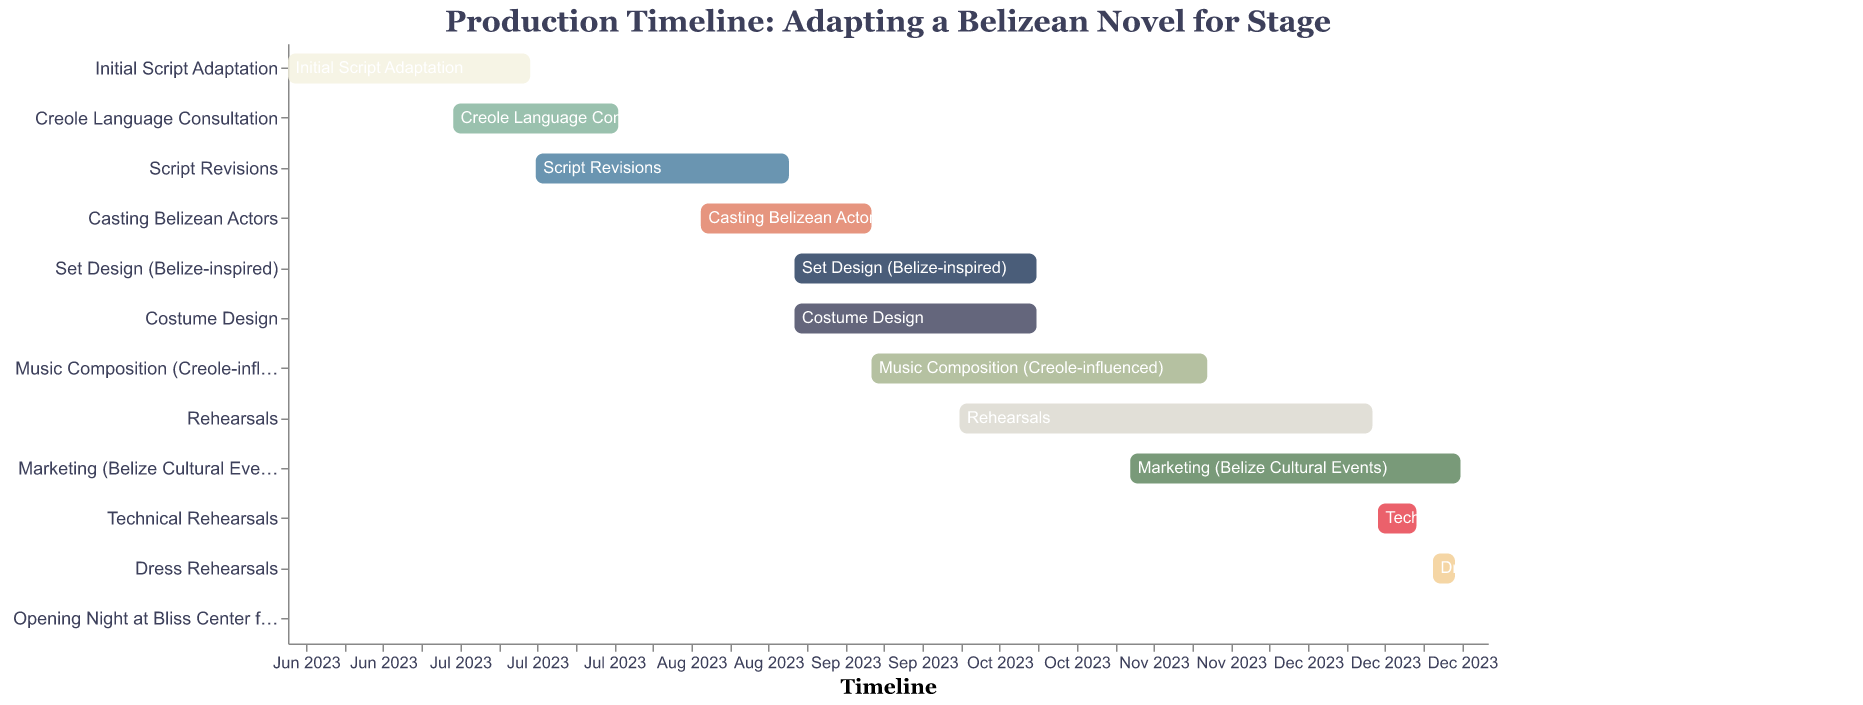What is the title of the Gantt Chart? The title of the chart is stated at the top of the figure, and it reads "Production Timeline: Adapting a Belizean Novel for Stage".
Answer: Production Timeline: Adapting a Belizean Novel for Stage Which task starts on 2023-09-01 and ends on 2023-10-15? By looking at the chart and examining tasks that span from 2023-09-01 to 2023-10-15, "Set Design (Belize-inspired)" and "Costume Design" fit these criteria.
Answer: Set Design (Belize-inspired), Costume Design How long does the "Rehearsals" task last? Observing the timeline for "Rehearsals", the task starts on 2023-10-01 and ends on 2023-12-15. To find the duration, count the months: October, November, and half of December, which totals to approximately 2.5 months.
Answer: 2.5 months Which task directly follows the "Initial Script Adaptation"? The "Initial Script Adaptation" ends on 2023-07-15. The next task starting after this date is "Script Revisions", which starts on 2023-07-16.
Answer: Script Revisions What is the time overlap between "Music Composition (Creole-influenced)" and "Rehearsals"? "Music Composition (Creole-influenced)" starts on 2023-09-15 and ends on 2023-11-15. "Rehearsals" starts on 2023-10-01 and ends on 2023-12-15. The overlap is from 2023-10-01 to 2023-11-15, which is 1.5 months.
Answer: 1.5 months How many tasks are related to design? Observing the Gantt Chart, "Set Design (Belize-inspired)" and "Costume Design" are tasks specifically related to design; hence there are two.
Answer: 2 What is the shortest task in the timeline? The shortest task in the timeline is "Opening Night at Bliss Center for Performing Arts", which occurs on one day, 2024-01-05.
Answer: Opening Night at Bliss Center for Performing Arts What is the duration of "Marketing (Belize Cultural Events)"? "Marketing (Belize Cultural Events)" starts on 2023-11-01 and ends on 2023-12-31. This period covers November and December, making it 2 months long.
Answer: 2 months When does "Casting Belizean Actors" start and end? The "Casting Belizean Actors" task starts on 2023-08-15 and ends on 2023-09-15, according to its position on the Gantt Chart.
Answer: 2023-08-15 to 2023-09-15 How many tasks are ongoing in September 2023? In September 2023, the following tasks are ongoing: "Casting Belizean Actors", "Set Design (Belize-inspired)", "Costume Design", and "Music Composition (Creole-influenced)". This totals to four tasks.
Answer: 4 